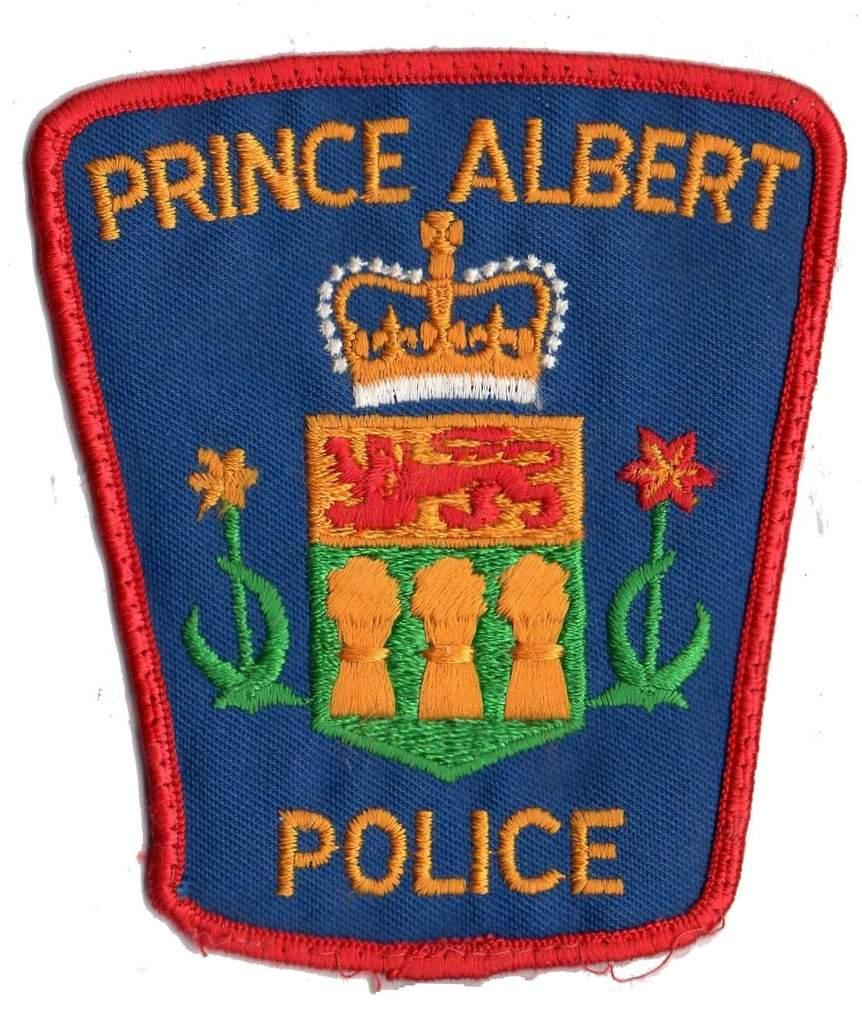What object is present in the image that has a design or symbol? There is a badge in the image. Can you describe the appearance of the badge? The badge is colorful. What can be found on the surface of the badge? There is writing on the badge. What color is the background of the image? The background of the image is white. How does the fowl react to the shock in the image? There is no fowl or shock present in the image; it only features a colorful badge with writing on a white background. 